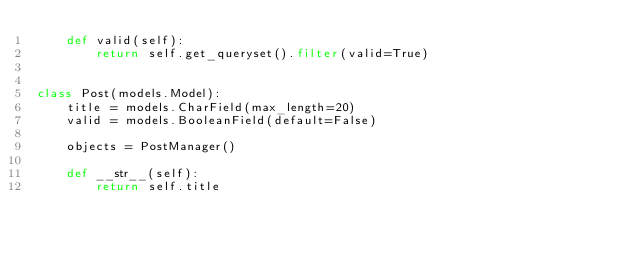<code> <loc_0><loc_0><loc_500><loc_500><_Python_>    def valid(self):
        return self.get_queryset().filter(valid=True)


class Post(models.Model):
    title = models.CharField(max_length=20)
    valid = models.BooleanField(default=False)

    objects = PostManager()

    def __str__(self):
        return self.title
</code> 